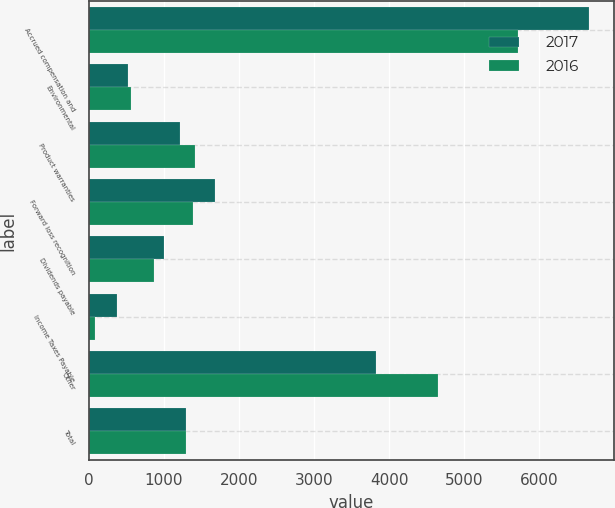<chart> <loc_0><loc_0><loc_500><loc_500><stacked_bar_chart><ecel><fcel>Accrued compensation and<fcel>Environmental<fcel>Product warranties<fcel>Forward loss recognition<fcel>Dividends payable<fcel>Income Taxes Payable<fcel>Other<fcel>Total<nl><fcel>2017<fcel>6659<fcel>524<fcel>1211<fcel>1683<fcel>1005<fcel>380<fcel>3830<fcel>1298<nl><fcel>2016<fcel>5720<fcel>562<fcel>1414<fcel>1385<fcel>866<fcel>89<fcel>4655<fcel>1298<nl></chart> 